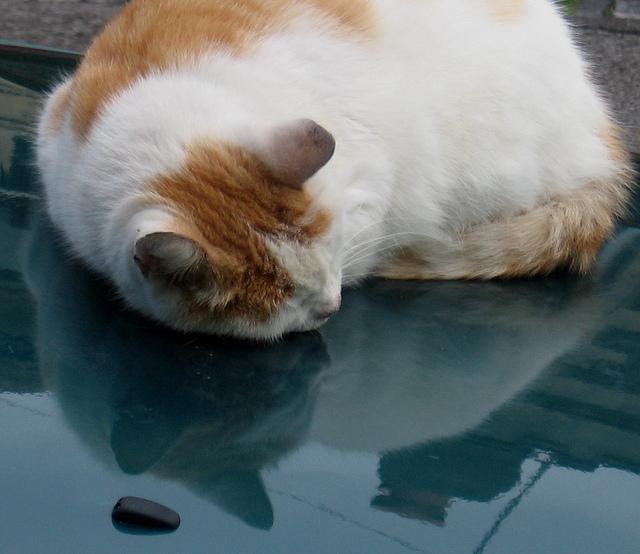Is the car blue?
Concise answer only. Yes. What color is the cat?
Keep it brief. Orange and white. Can you see the cats eyes?
Concise answer only. No. Where is the cat sleeping?
Keep it brief. On car. 